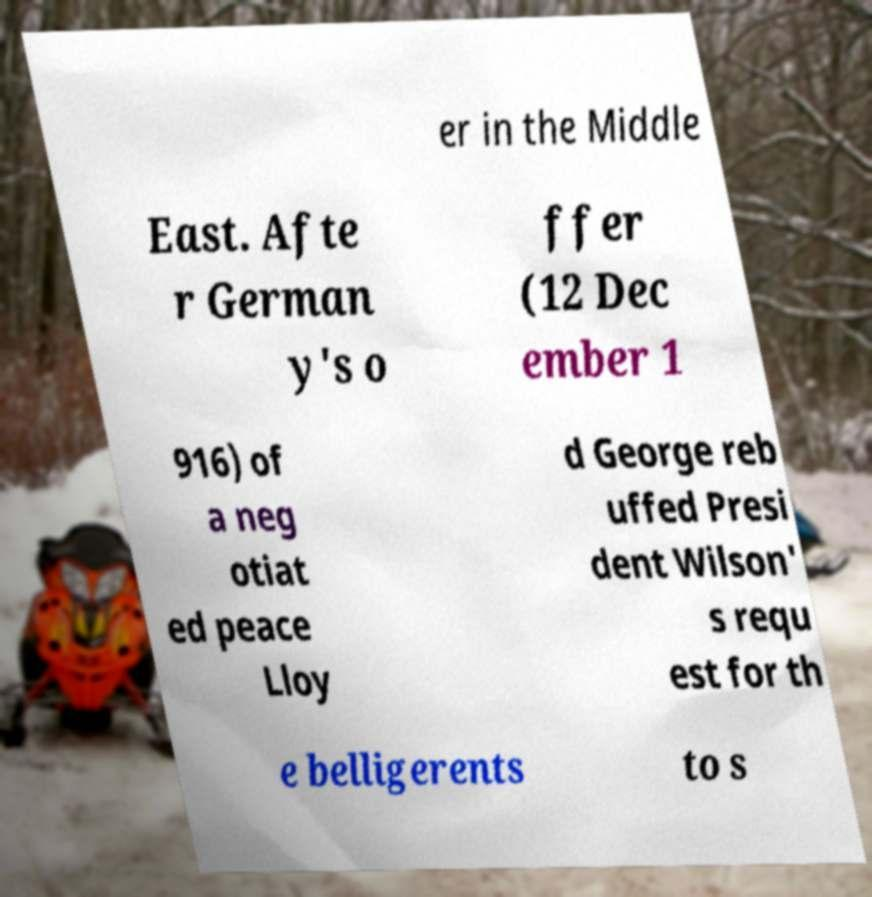Can you accurately transcribe the text from the provided image for me? er in the Middle East. Afte r German y's o ffer (12 Dec ember 1 916) of a neg otiat ed peace Lloy d George reb uffed Presi dent Wilson' s requ est for th e belligerents to s 